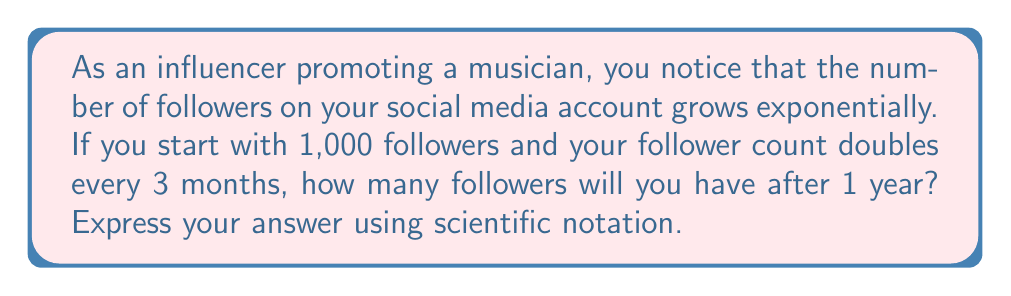Solve this math problem. Let's approach this step-by-step:

1) We start with an initial number of followers: $N_0 = 1,000$

2) The growth rate is doubling every 3 months, so in one year (12 months), the number will double 4 times.

3) We can express this using the exponential growth formula:
   $N(t) = N_0 \cdot 2^t$
   where $t$ is the number of 3-month periods.

4) After 1 year, $t = 4$ (since there are four 3-month periods in a year)

5) Let's substitute these values into our formula:
   $N(4) = 1,000 \cdot 2^4$

6) Calculate $2^4$:
   $2^4 = 2 \cdot 2 \cdot 2 \cdot 2 = 16$

7) Now our equation looks like:
   $N(4) = 1,000 \cdot 16 = 16,000$

8) To express this in scientific notation, we move the decimal point 4 places to the left:
   $16,000 = 1.6 \times 10^4$

Therefore, after 1 year, you will have $1.6 \times 10^4$ followers.
Answer: $1.6 \times 10^4$ 